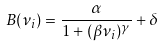Convert formula to latex. <formula><loc_0><loc_0><loc_500><loc_500>B ( \nu _ { i } ) = \frac { \alpha } { 1 + ( \beta \nu _ { i } ) ^ { \gamma } } + \delta</formula> 